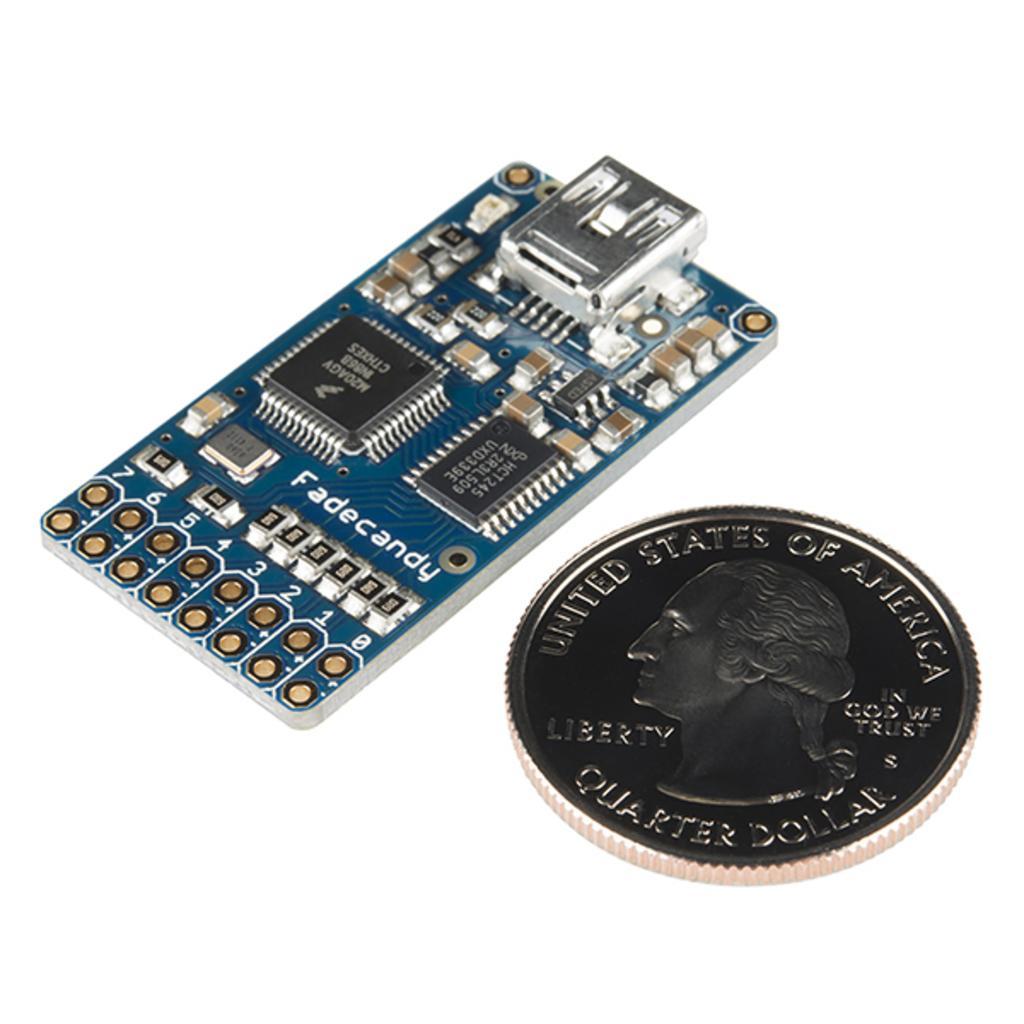Could you give a brief overview of what you see in this image? This is an electronic circuit board, in the right side it is a coin. 